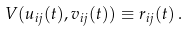<formula> <loc_0><loc_0><loc_500><loc_500>V ( u _ { i j } ( t ) , v _ { i j } ( t ) ) \equiv r _ { i j } ( t ) \, .</formula> 